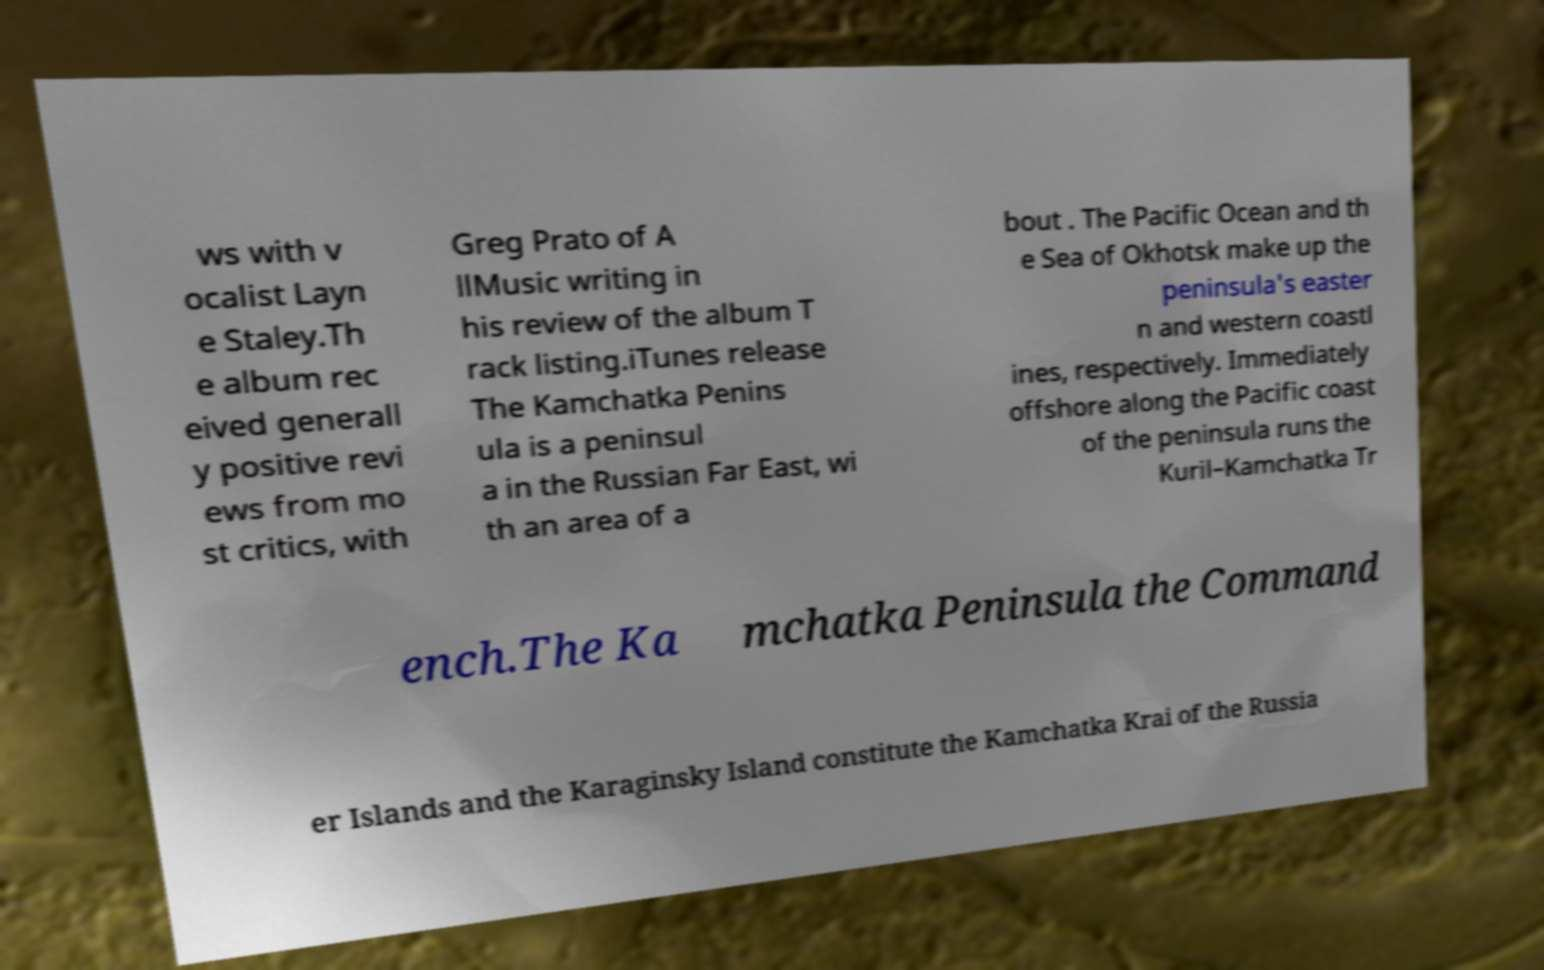Please read and relay the text visible in this image. What does it say? ws with v ocalist Layn e Staley.Th e album rec eived generall y positive revi ews from mo st critics, with Greg Prato of A llMusic writing in his review of the album T rack listing.iTunes release The Kamchatka Penins ula is a peninsul a in the Russian Far East, wi th an area of a bout . The Pacific Ocean and th e Sea of Okhotsk make up the peninsula's easter n and western coastl ines, respectively. Immediately offshore along the Pacific coast of the peninsula runs the Kuril–Kamchatka Tr ench.The Ka mchatka Peninsula the Command er Islands and the Karaginsky Island constitute the Kamchatka Krai of the Russia 